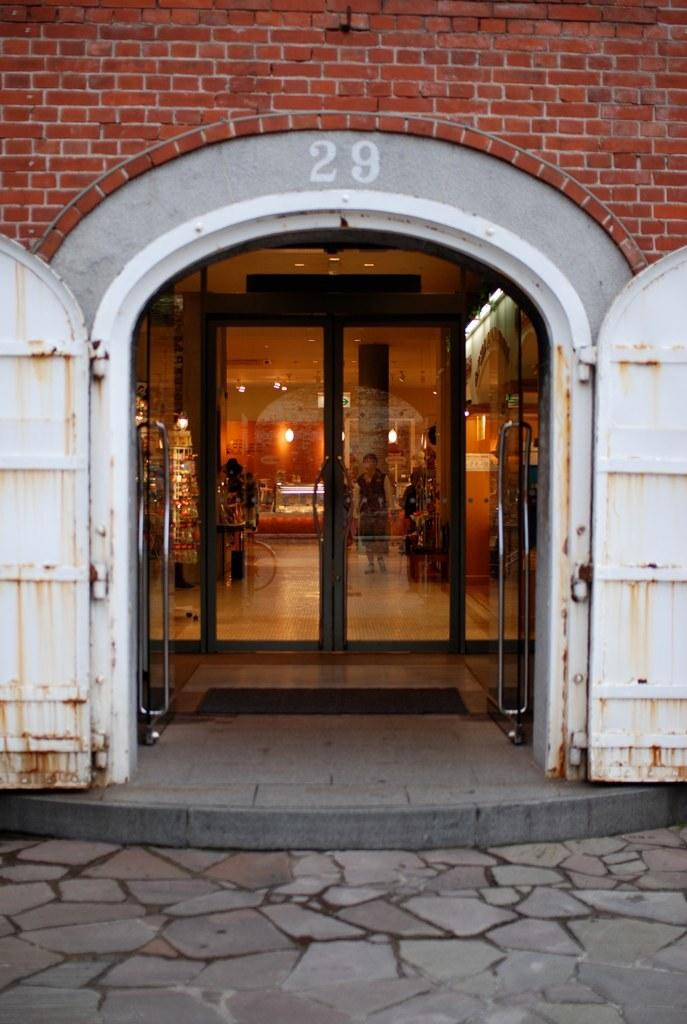What type of structure can be seen in the image? There is a wall in the image. Are there any openings in the wall? Yes, there are doors in the image. What is the surface beneath the people and objects in the image? There is a floor in the image. What provides illumination in the image? There are lights in the image. Is there any support structure visible in the image? Yes, there is a pillar in the image. Can you describe the people present in the image? There are people in the image. What else can be seen in the image besides the people? There are objects in the image. What is the distribution of flies in the image? There are no flies present in the image, so it is not possible to determine their distribution. 